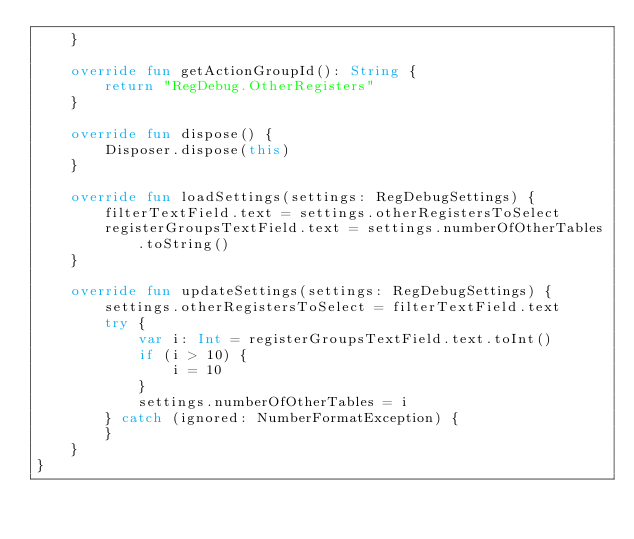<code> <loc_0><loc_0><loc_500><loc_500><_Kotlin_>    }

    override fun getActionGroupId(): String {
        return "RegDebug.OtherRegisters"
    }

    override fun dispose() {
        Disposer.dispose(this)
    }

    override fun loadSettings(settings: RegDebugSettings) {
        filterTextField.text = settings.otherRegistersToSelect
        registerGroupsTextField.text = settings.numberOfOtherTables.toString()
    }

    override fun updateSettings(settings: RegDebugSettings) {
        settings.otherRegistersToSelect = filterTextField.text
        try {
            var i: Int = registerGroupsTextField.text.toInt()
            if (i > 10) {
                i = 10
            }
            settings.numberOfOtherTables = i
        } catch (ignored: NumberFormatException) {
        }
    }
}
</code> 